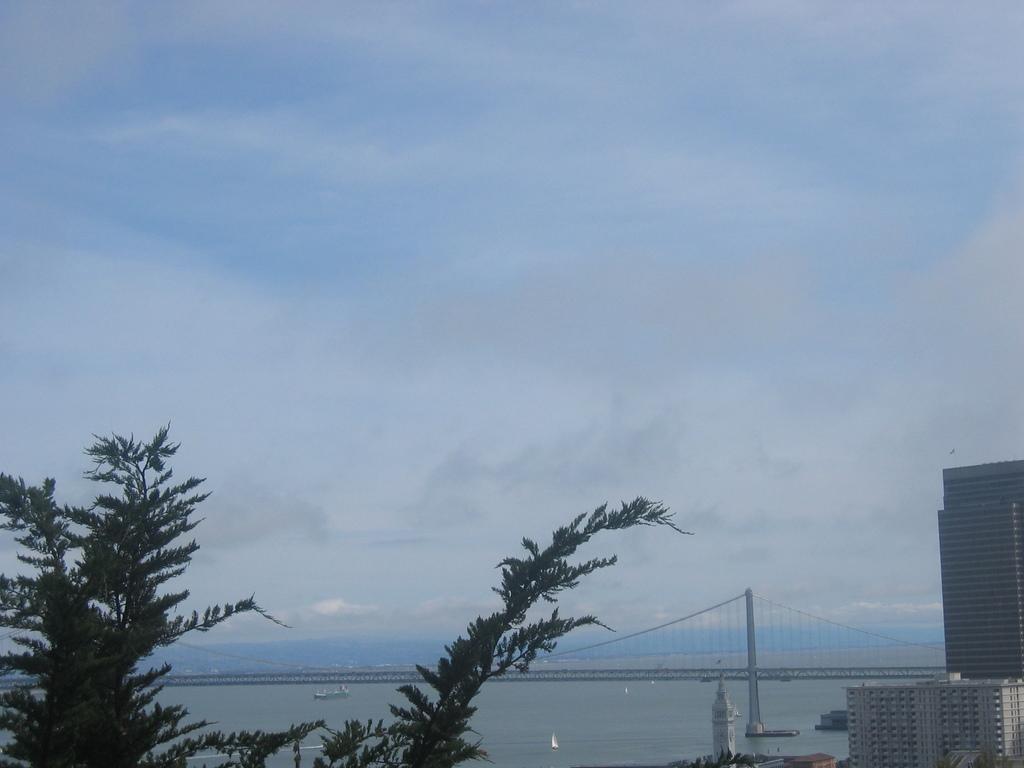In one or two sentences, can you explain what this image depicts? In this image there is the sky towards the top of the image, there are clouds in the sky, there is a sea, there is a boat on the sea, there is a bridge, there are buildings towards the right of the image, there are trees towards the bottom of the image. 